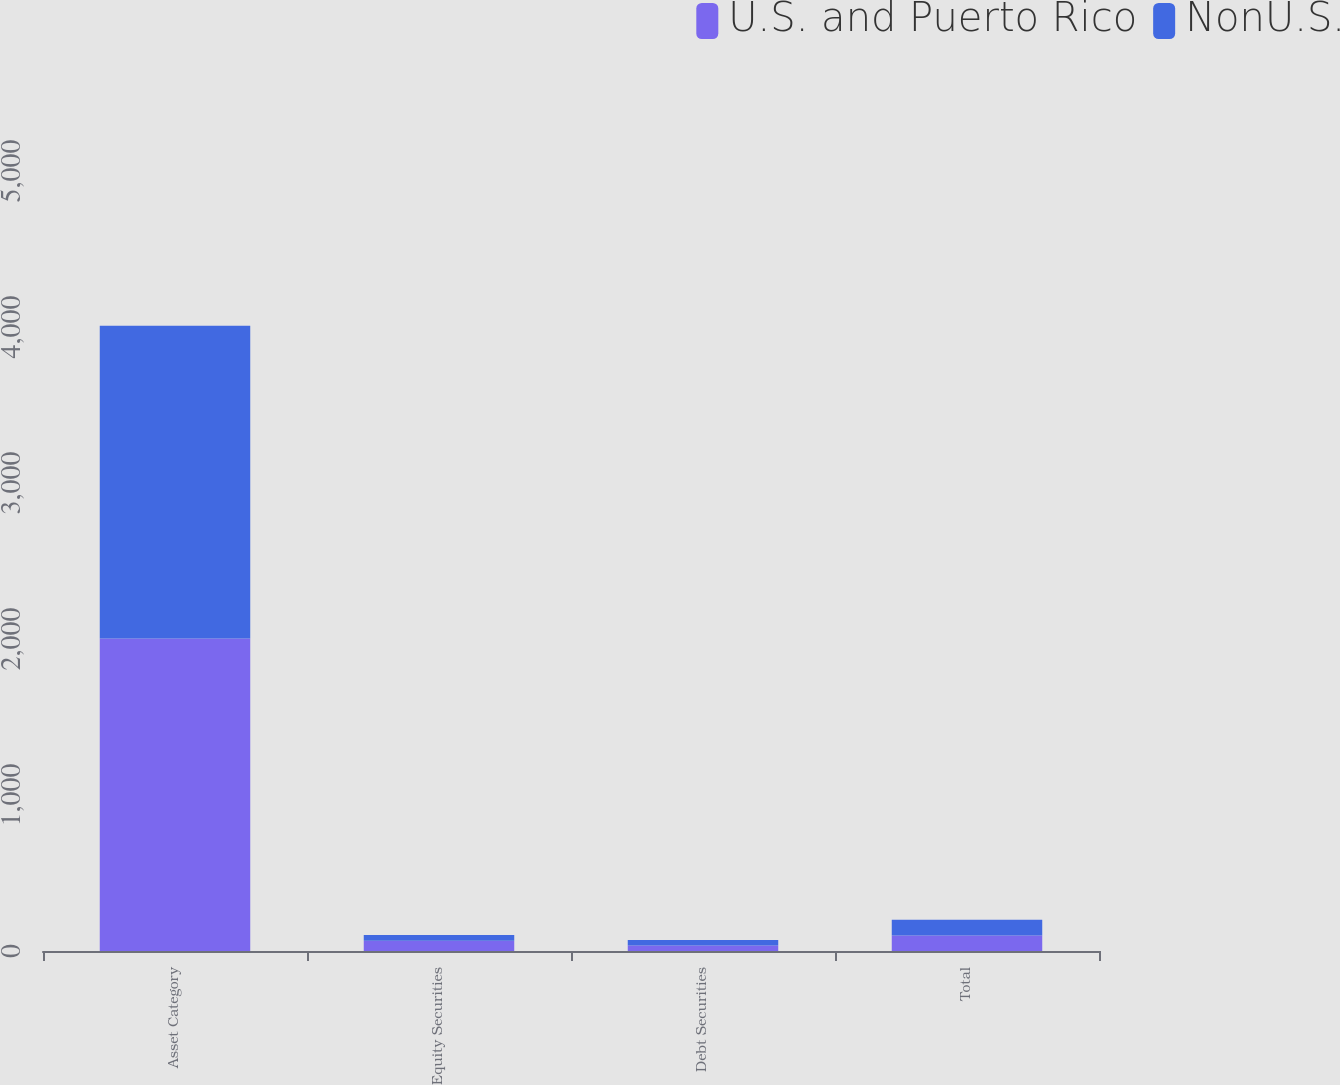Convert chart. <chart><loc_0><loc_0><loc_500><loc_500><stacked_bar_chart><ecel><fcel>Asset Category<fcel>Equity Securities<fcel>Debt Securities<fcel>Total<nl><fcel>U.S. and Puerto Rico<fcel>2004<fcel>65<fcel>35<fcel>100<nl><fcel>NonU.S.<fcel>2004<fcel>37<fcel>35<fcel>100<nl></chart> 